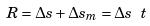Convert formula to latex. <formula><loc_0><loc_0><loc_500><loc_500>R = \Delta s + \Delta s _ { m } = \Delta s \ t</formula> 